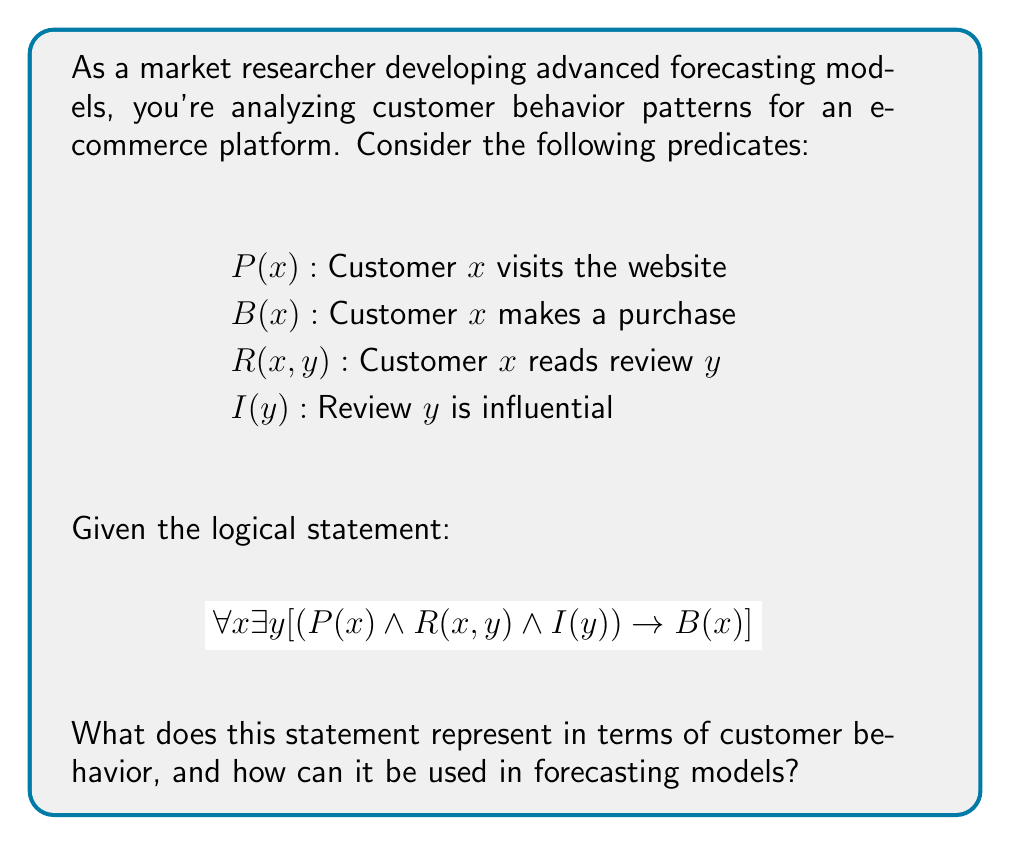Teach me how to tackle this problem. Let's break down this logical statement and interpret it in the context of customer behavior:

1. $\forall x$: For all customers $x$
2. $\exists y$: There exists a review $y$
3. $P(x)$: Customer $x$ visits the website
4. $R(x,y)$: Customer $x$ reads review $y$
5. $I(y)$: Review $y$ is influential
6. $B(x)$: Customer $x$ makes a purchase

The complete statement $$\forall x \exists y [(P(x) \wedge R(x,y) \wedge I(y)) \rightarrow B(x)]$$ can be interpreted as:

For all customers, there exists an influential review such that if the customer visits the website and reads that influential review, then the customer makes a purchase.

In terms of customer behavior, this statement represents a pattern where:
1. Website visits alone don't guarantee purchases
2. Reading reviews influences purchasing decisions
3. Not all reviews are equally impactful; only influential ones lead to purchases

For forecasting models, this logical statement can be used to:

1. Predict purchase likelihood based on website visits and review interactions
2. Identify and promote influential reviews to increase conversion rates
3. Segment customers based on their responsiveness to reviews
4. Develop targeted marketing strategies focusing on review-driven purchases

By incorporating this predicate logic into forecasting models, market researchers can create more accurate predictions of customer behavior, taking into account the impact of influential reviews on purchasing decisions.
Answer: The statement represents a customer behavior pattern where website visits combined with reading influential reviews lead to purchases, useful for predicting conversion rates and developing targeted marketing strategies in forecasting models. 